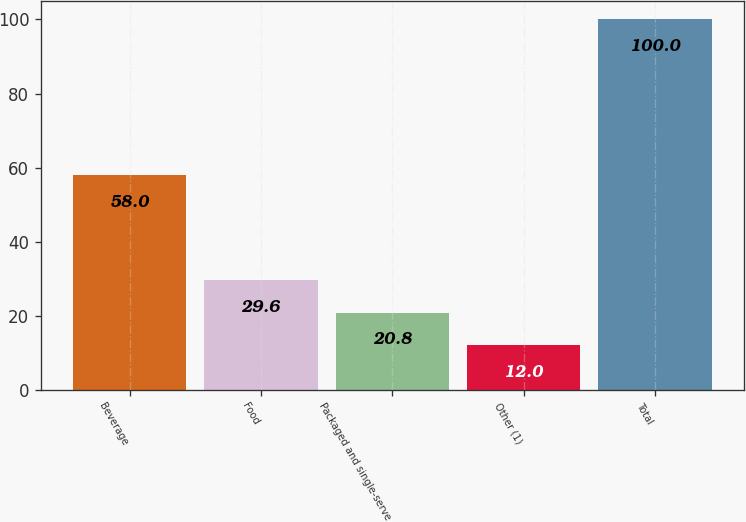Convert chart. <chart><loc_0><loc_0><loc_500><loc_500><bar_chart><fcel>Beverage<fcel>Food<fcel>Packaged and single-serve<fcel>Other (1)<fcel>Total<nl><fcel>58<fcel>29.6<fcel>20.8<fcel>12<fcel>100<nl></chart> 